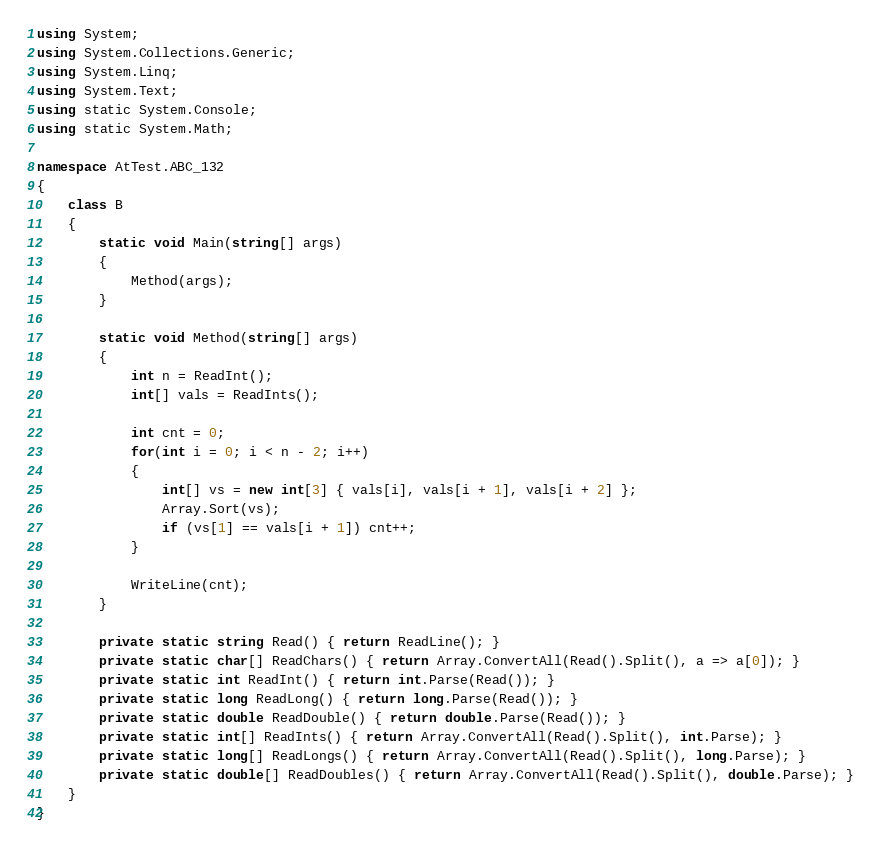<code> <loc_0><loc_0><loc_500><loc_500><_C#_>using System;
using System.Collections.Generic;
using System.Linq;
using System.Text;
using static System.Console;
using static System.Math;

namespace AtTest.ABC_132
{
    class B
    {
        static void Main(string[] args)
        {
            Method(args);
        }

        static void Method(string[] args)
        {
            int n = ReadInt();
            int[] vals = ReadInts();

            int cnt = 0;
            for(int i = 0; i < n - 2; i++)
            {
                int[] vs = new int[3] { vals[i], vals[i + 1], vals[i + 2] };
                Array.Sort(vs);
                if (vs[1] == vals[i + 1]) cnt++;
            }

            WriteLine(cnt);
        }

        private static string Read() { return ReadLine(); }
        private static char[] ReadChars() { return Array.ConvertAll(Read().Split(), a => a[0]); }
        private static int ReadInt() { return int.Parse(Read()); }
        private static long ReadLong() { return long.Parse(Read()); }
        private static double ReadDouble() { return double.Parse(Read()); }
        private static int[] ReadInts() { return Array.ConvertAll(Read().Split(), int.Parse); }
        private static long[] ReadLongs() { return Array.ConvertAll(Read().Split(), long.Parse); }
        private static double[] ReadDoubles() { return Array.ConvertAll(Read().Split(), double.Parse); }
    }
}
</code> 